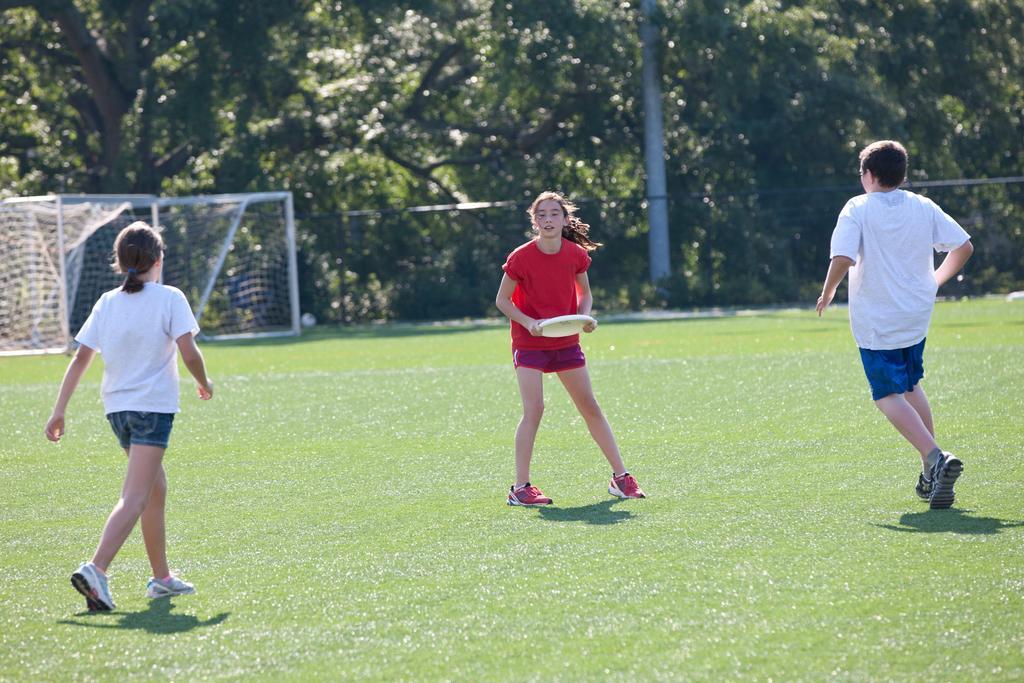Could you give a brief overview of what you see in this image? This person is holding a disc. Here we can see two people. Far there is a mesh, trees and pole. 